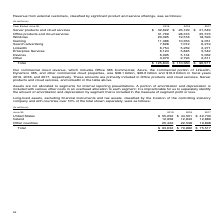According to Microsoft Corporation's financial document, What does the company's commercial cloud revenue contain? Office 365 Commercial, Azure, the commercial portion of LinkedIn, Dynamics 365, and other commercial cloud properties. The document states: "Our commercial cloud revenue, which includes Office 365 Commercial, Azure, the commercial portion of LinkedIn, Dynamics 365, and other commercial clou..." Also, How much revenue did the commercial cloud area generate in 2017? According to the financial document, $16.2 billion. The relevant text states: "d properties, was $38.1 billion, $26.6 billion and $16.2 billion in fiscal years 2019, 2018, and 2017, respectively. These amounts are primarily included in Office p..." Also, How much revenue came from LinkedIn in 2019? According to the financial document, 6,754 (in millions). The relevant text states: "LinkedIn 6,754 5,259 2,271..." Also, How many revenue items are there? Counting the relevant items in the document: Server products and cloud services,  Office products and cloud services,  Windows,  Gaming,  Search advertising,  LinkedIn,  Enterprise Services,  Devices,  Other, I find 9 instances. The key data points involved are: Devices, Enterprise Services, Gaming. Also, can you calculate: How much of the total revenue in 2019 did not come from commercial cloud revenue? Based on the calculation: 125,843 million - 38.1 billion , the result is 87743 (in millions). This is based on the information: "Total $ 125,843 $ 110,360 $ 96,571 365, and other commercial cloud properties, was $38.1 billion, $26.6 billion and $16.2 billion in fiscal years 2019, 2018, and 2017, respectively. These..." The key data points involved are: 125,843, 38.1. Additionally, Which were the bottom 2 revenue items for 2017? The document shows two values: LinkedIn and Other. From the document: "LinkedIn 6,754 5,259 2,271 Other 3,070 2,793 2,611..." 